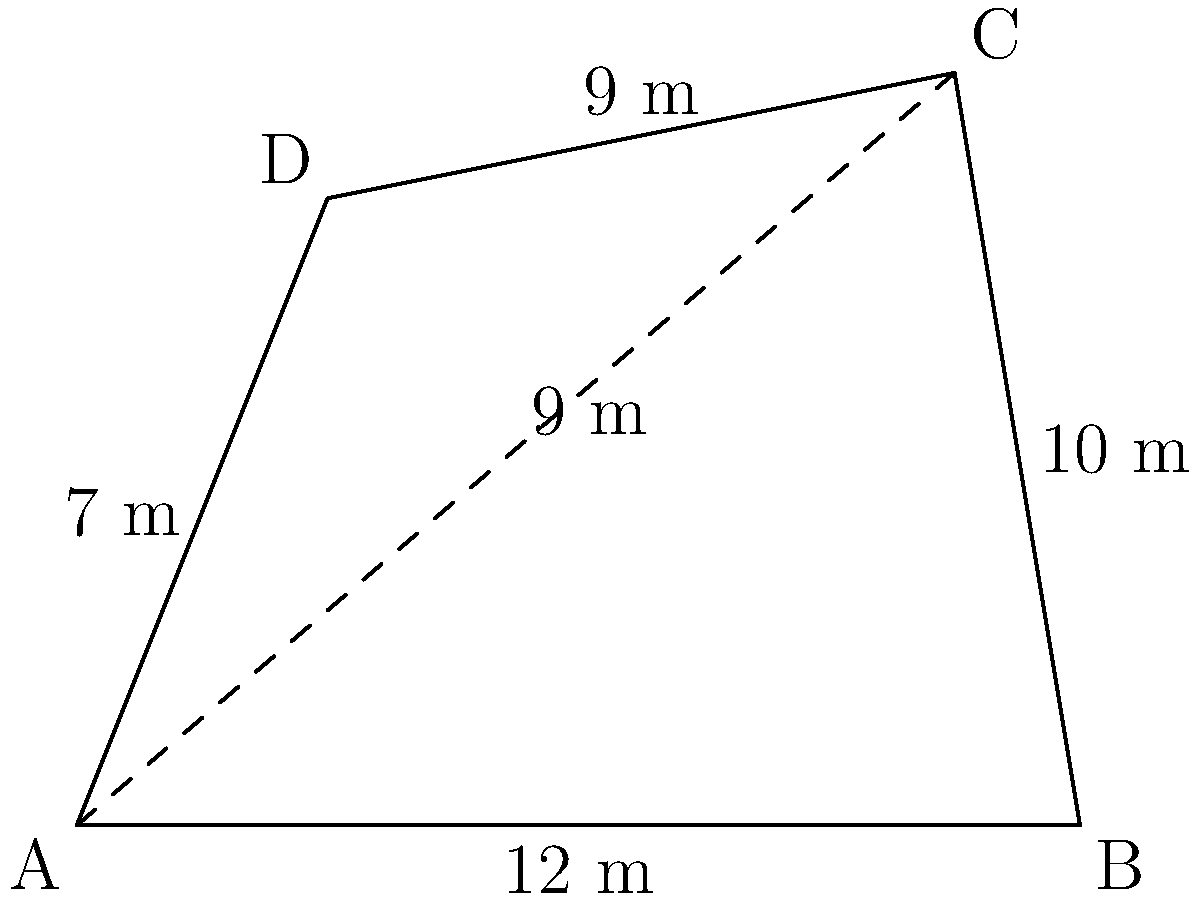In the medieval town of Wickhamford, the central square is represented by an irregular quadrilateral ABCD. The lengths of the sides are: AB = 12 m, BC = 10 m, CD = 9 m, and DA = 7 m. The diagonal AC measures 9 m. Calculate the area of the town square in square meters. To calculate the area of the irregular quadrilateral, we can divide it into two triangles using the diagonal AC. Let's solve this step-by-step:

1) We'll use Heron's formula to calculate the areas of triangles ABC and ACD.

2) Heron's formula: $A = \sqrt{s(s-a)(s-b)(s-c)}$, where $s = \frac{a+b+c}{2}$ (semi-perimeter)

3) For triangle ABC:
   $a = 12$, $b = 10$, $c = 9$
   $s = \frac{12 + 10 + 9}{2} = \frac{31}{2} = 15.5$
   $A_{ABC} = \sqrt{15.5(15.5-12)(15.5-10)(15.5-9)}$
   $A_{ABC} = \sqrt{15.5 \times 3.5 \times 5.5 \times 6.5} = 45.54$ m²

4) For triangle ACD:
   $a = 9$, $b = 9$, $c = 7$
   $s = \frac{9 + 9 + 7}{2} = \frac{25}{2} = 12.5$
   $A_{ACD} = \sqrt{12.5(12.5-9)(12.5-9)(12.5-7)}$
   $A_{ACD} = \sqrt{12.5 \times 3.5 \times 3.5 \times 5.5} = 31.72$ m²

5) The total area of the quadrilateral is the sum of these two triangles:
   $A_{total} = A_{ABC} + A_{ACD} = 45.54 + 31.72 = 77.26$ m²

Therefore, the area of the town square is approximately 77.26 square meters.
Answer: 77.26 m² 